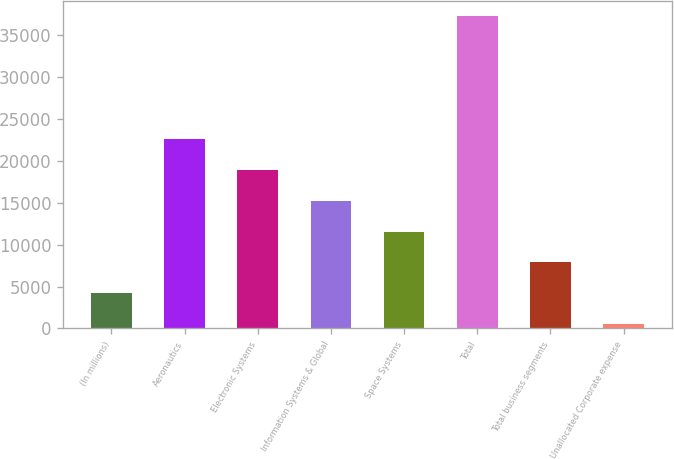Convert chart. <chart><loc_0><loc_0><loc_500><loc_500><bar_chart><fcel>(In millions)<fcel>Aeronautics<fcel>Electronic Systems<fcel>Information Systems & Global<fcel>Space Systems<fcel>Total<fcel>Total business segments<fcel>Unallocated Corporate expense<nl><fcel>4232.5<fcel>22555<fcel>18890.5<fcel>15226<fcel>11561.5<fcel>37213<fcel>7897<fcel>568<nl></chart> 